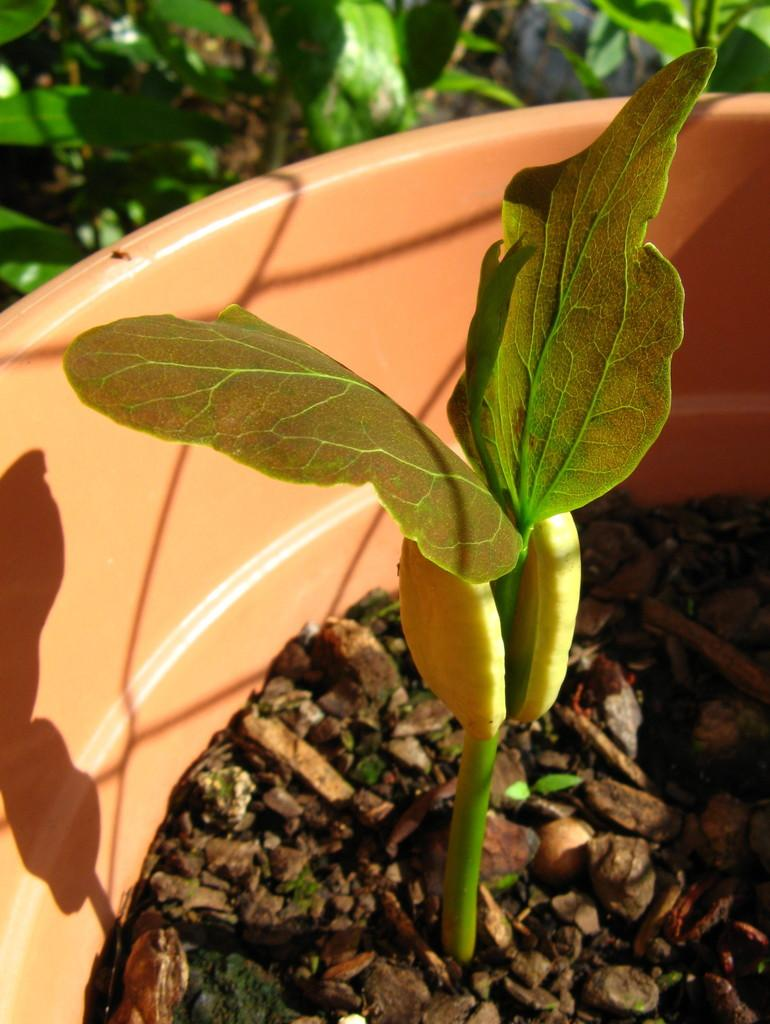What is the main object in the image? There is a pot in the image. What is inside the pot? The pot contains brown-colored things. What type of plant is in the pot? There is a plant in the pot. What else can be seen in the background of the image? There are additional plants visible in the background. What type of canvas is visible in the image? There is no canvas present in the image. What type of alley can be seen in the background of the image? There is no alley present in the image; it features a pot with a plant and additional plants in the background. 